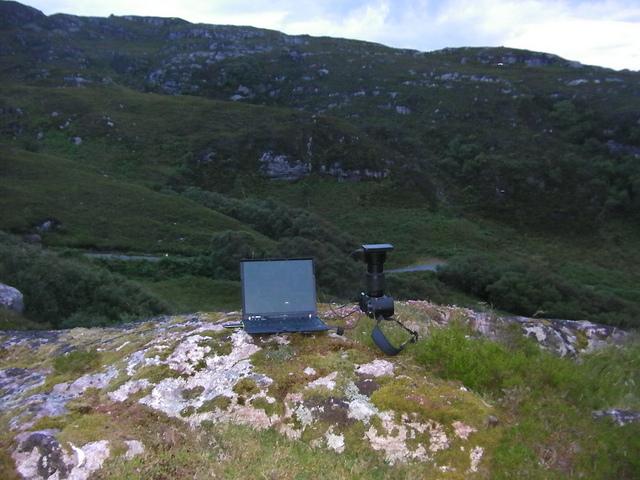Is there electricity here?
Answer briefly. No. Is there a computer in the picture?
Answer briefly. Yes. Is the sky overcast?
Quick response, please. Yes. 